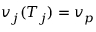Convert formula to latex. <formula><loc_0><loc_0><loc_500><loc_500>v _ { j } ( T _ { j } ) = v _ { p }</formula> 